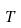Convert formula to latex. <formula><loc_0><loc_0><loc_500><loc_500>T</formula> 